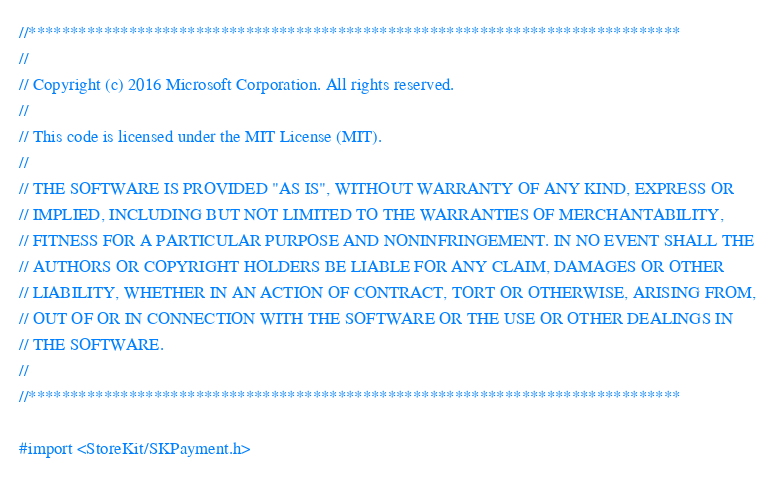Convert code to text. <code><loc_0><loc_0><loc_500><loc_500><_ObjectiveC_>//******************************************************************************
//
// Copyright (c) 2016 Microsoft Corporation. All rights reserved.
//
// This code is licensed under the MIT License (MIT).
//
// THE SOFTWARE IS PROVIDED "AS IS", WITHOUT WARRANTY OF ANY KIND, EXPRESS OR
// IMPLIED, INCLUDING BUT NOT LIMITED TO THE WARRANTIES OF MERCHANTABILITY,
// FITNESS FOR A PARTICULAR PURPOSE AND NONINFRINGEMENT. IN NO EVENT SHALL THE
// AUTHORS OR COPYRIGHT HOLDERS BE LIABLE FOR ANY CLAIM, DAMAGES OR OTHER
// LIABILITY, WHETHER IN AN ACTION OF CONTRACT, TORT OR OTHERWISE, ARISING FROM,
// OUT OF OR IN CONNECTION WITH THE SOFTWARE OR THE USE OR OTHER DEALINGS IN
// THE SOFTWARE.
//
//******************************************************************************

#import <StoreKit/SKPayment.h></code> 